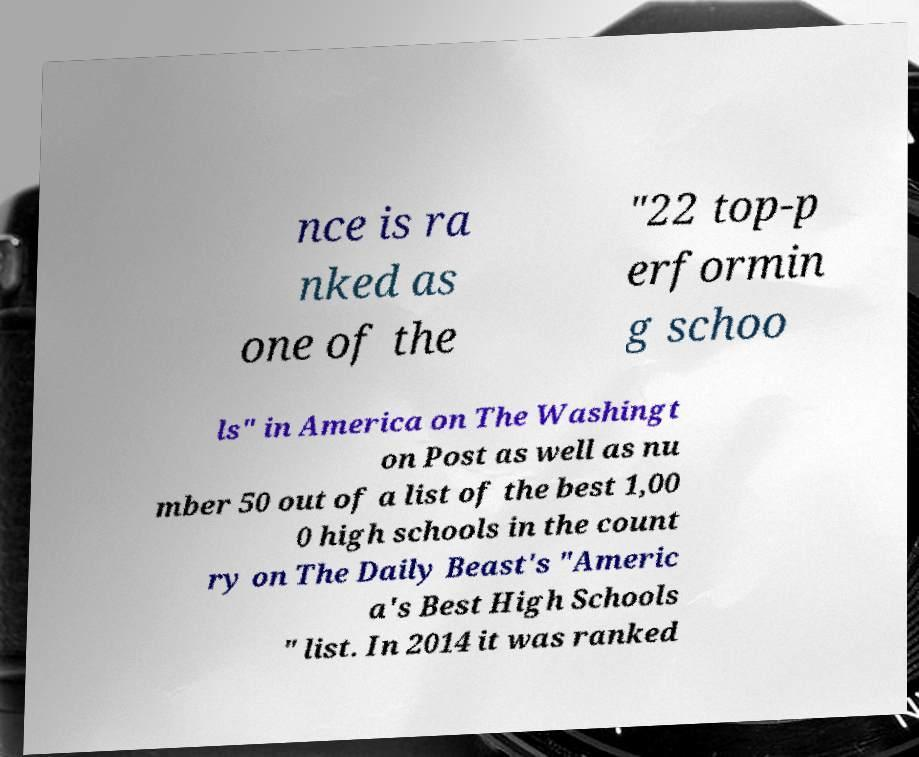There's text embedded in this image that I need extracted. Can you transcribe it verbatim? nce is ra nked as one of the "22 top-p erformin g schoo ls" in America on The Washingt on Post as well as nu mber 50 out of a list of the best 1,00 0 high schools in the count ry on The Daily Beast's "Americ a's Best High Schools " list. In 2014 it was ranked 